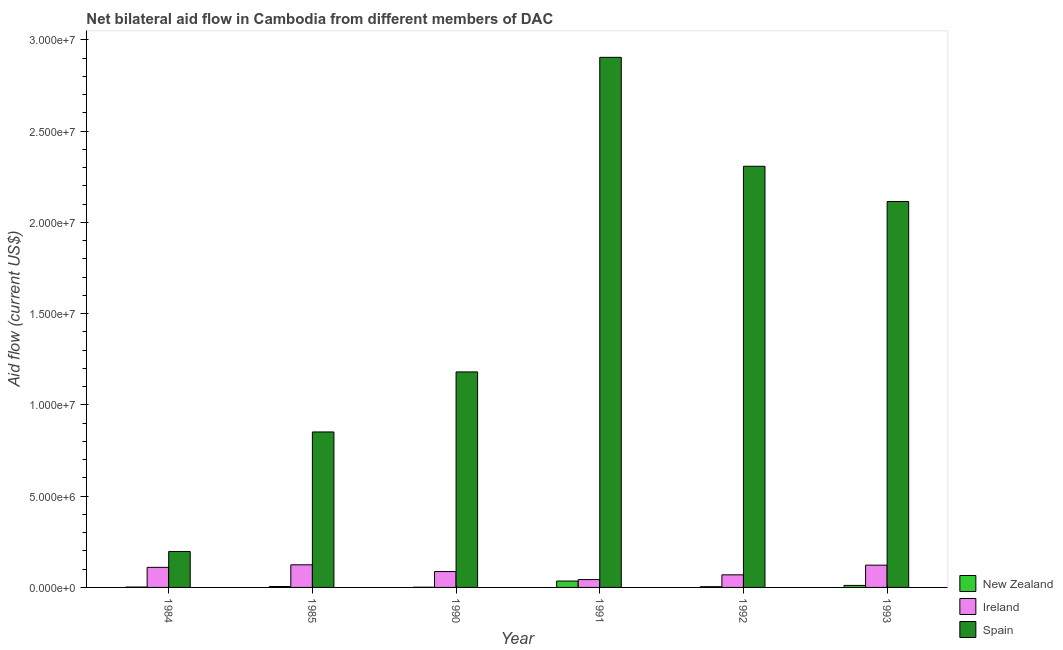Are the number of bars per tick equal to the number of legend labels?
Ensure brevity in your answer.  Yes. How many bars are there on the 4th tick from the left?
Keep it short and to the point. 3. How many bars are there on the 1st tick from the right?
Ensure brevity in your answer.  3. What is the label of the 3rd group of bars from the left?
Offer a terse response. 1990. In how many cases, is the number of bars for a given year not equal to the number of legend labels?
Keep it short and to the point. 0. What is the amount of aid provided by spain in 1993?
Provide a succinct answer. 2.12e+07. Across all years, what is the maximum amount of aid provided by ireland?
Your response must be concise. 1.24e+06. Across all years, what is the minimum amount of aid provided by new zealand?
Provide a succinct answer. 10000. What is the total amount of aid provided by new zealand in the graph?
Provide a succinct answer. 5.80e+05. What is the difference between the amount of aid provided by spain in 1990 and that in 1991?
Your answer should be very brief. -1.72e+07. What is the difference between the amount of aid provided by spain in 1991 and the amount of aid provided by new zealand in 1992?
Give a very brief answer. 5.97e+06. What is the average amount of aid provided by ireland per year?
Your answer should be very brief. 9.25e+05. In the year 1991, what is the difference between the amount of aid provided by spain and amount of aid provided by ireland?
Ensure brevity in your answer.  0. In how many years, is the amount of aid provided by ireland greater than 15000000 US$?
Offer a very short reply. 0. What is the ratio of the amount of aid provided by ireland in 1985 to that in 1991?
Your answer should be compact. 2.88. What is the difference between the highest and the second highest amount of aid provided by spain?
Make the answer very short. 5.97e+06. What is the difference between the highest and the lowest amount of aid provided by new zealand?
Give a very brief answer. 3.40e+05. Is the sum of the amount of aid provided by spain in 1984 and 1993 greater than the maximum amount of aid provided by ireland across all years?
Offer a terse response. No. What does the 2nd bar from the left in 1993 represents?
Your response must be concise. Ireland. What does the 2nd bar from the right in 1985 represents?
Give a very brief answer. Ireland. Is it the case that in every year, the sum of the amount of aid provided by new zealand and amount of aid provided by ireland is greater than the amount of aid provided by spain?
Make the answer very short. No. Are all the bars in the graph horizontal?
Your answer should be very brief. No. What is the difference between two consecutive major ticks on the Y-axis?
Keep it short and to the point. 5.00e+06. Does the graph contain any zero values?
Provide a short and direct response. No. Where does the legend appear in the graph?
Ensure brevity in your answer.  Bottom right. How many legend labels are there?
Provide a short and direct response. 3. How are the legend labels stacked?
Keep it short and to the point. Vertical. What is the title of the graph?
Your response must be concise. Net bilateral aid flow in Cambodia from different members of DAC. What is the label or title of the X-axis?
Provide a short and direct response. Year. What is the label or title of the Y-axis?
Your answer should be very brief. Aid flow (current US$). What is the Aid flow (current US$) in New Zealand in 1984?
Make the answer very short. 2.00e+04. What is the Aid flow (current US$) of Ireland in 1984?
Provide a short and direct response. 1.10e+06. What is the Aid flow (current US$) of Spain in 1984?
Offer a terse response. 1.97e+06. What is the Aid flow (current US$) in New Zealand in 1985?
Your answer should be very brief. 5.00e+04. What is the Aid flow (current US$) of Ireland in 1985?
Provide a short and direct response. 1.24e+06. What is the Aid flow (current US$) of Spain in 1985?
Give a very brief answer. 8.52e+06. What is the Aid flow (current US$) of New Zealand in 1990?
Provide a short and direct response. 10000. What is the Aid flow (current US$) in Ireland in 1990?
Offer a very short reply. 8.70e+05. What is the Aid flow (current US$) of Spain in 1990?
Your response must be concise. 1.18e+07. What is the Aid flow (current US$) of New Zealand in 1991?
Make the answer very short. 3.50e+05. What is the Aid flow (current US$) in Ireland in 1991?
Ensure brevity in your answer.  4.30e+05. What is the Aid flow (current US$) in Spain in 1991?
Make the answer very short. 2.90e+07. What is the Aid flow (current US$) in Ireland in 1992?
Give a very brief answer. 6.90e+05. What is the Aid flow (current US$) of Spain in 1992?
Ensure brevity in your answer.  2.31e+07. What is the Aid flow (current US$) of Ireland in 1993?
Make the answer very short. 1.22e+06. What is the Aid flow (current US$) in Spain in 1993?
Your response must be concise. 2.12e+07. Across all years, what is the maximum Aid flow (current US$) in Ireland?
Your response must be concise. 1.24e+06. Across all years, what is the maximum Aid flow (current US$) of Spain?
Your answer should be compact. 2.90e+07. Across all years, what is the minimum Aid flow (current US$) of New Zealand?
Ensure brevity in your answer.  10000. Across all years, what is the minimum Aid flow (current US$) in Spain?
Offer a terse response. 1.97e+06. What is the total Aid flow (current US$) in New Zealand in the graph?
Your answer should be very brief. 5.80e+05. What is the total Aid flow (current US$) in Ireland in the graph?
Ensure brevity in your answer.  5.55e+06. What is the total Aid flow (current US$) of Spain in the graph?
Ensure brevity in your answer.  9.56e+07. What is the difference between the Aid flow (current US$) of New Zealand in 1984 and that in 1985?
Give a very brief answer. -3.00e+04. What is the difference between the Aid flow (current US$) of Spain in 1984 and that in 1985?
Give a very brief answer. -6.55e+06. What is the difference between the Aid flow (current US$) of New Zealand in 1984 and that in 1990?
Offer a terse response. 10000. What is the difference between the Aid flow (current US$) in Ireland in 1984 and that in 1990?
Offer a terse response. 2.30e+05. What is the difference between the Aid flow (current US$) of Spain in 1984 and that in 1990?
Provide a short and direct response. -9.84e+06. What is the difference between the Aid flow (current US$) of New Zealand in 1984 and that in 1991?
Your answer should be very brief. -3.30e+05. What is the difference between the Aid flow (current US$) in Ireland in 1984 and that in 1991?
Your answer should be very brief. 6.70e+05. What is the difference between the Aid flow (current US$) in Spain in 1984 and that in 1991?
Your response must be concise. -2.71e+07. What is the difference between the Aid flow (current US$) in Spain in 1984 and that in 1992?
Give a very brief answer. -2.11e+07. What is the difference between the Aid flow (current US$) of New Zealand in 1984 and that in 1993?
Ensure brevity in your answer.  -9.00e+04. What is the difference between the Aid flow (current US$) of Spain in 1984 and that in 1993?
Offer a terse response. -1.92e+07. What is the difference between the Aid flow (current US$) of Ireland in 1985 and that in 1990?
Offer a very short reply. 3.70e+05. What is the difference between the Aid flow (current US$) of Spain in 1985 and that in 1990?
Your response must be concise. -3.29e+06. What is the difference between the Aid flow (current US$) of New Zealand in 1985 and that in 1991?
Offer a terse response. -3.00e+05. What is the difference between the Aid flow (current US$) in Ireland in 1985 and that in 1991?
Keep it short and to the point. 8.10e+05. What is the difference between the Aid flow (current US$) of Spain in 1985 and that in 1991?
Provide a short and direct response. -2.05e+07. What is the difference between the Aid flow (current US$) of New Zealand in 1985 and that in 1992?
Your answer should be very brief. 10000. What is the difference between the Aid flow (current US$) in Spain in 1985 and that in 1992?
Provide a succinct answer. -1.46e+07. What is the difference between the Aid flow (current US$) of Ireland in 1985 and that in 1993?
Your response must be concise. 2.00e+04. What is the difference between the Aid flow (current US$) of Spain in 1985 and that in 1993?
Provide a succinct answer. -1.26e+07. What is the difference between the Aid flow (current US$) of New Zealand in 1990 and that in 1991?
Ensure brevity in your answer.  -3.40e+05. What is the difference between the Aid flow (current US$) in Ireland in 1990 and that in 1991?
Keep it short and to the point. 4.40e+05. What is the difference between the Aid flow (current US$) of Spain in 1990 and that in 1991?
Make the answer very short. -1.72e+07. What is the difference between the Aid flow (current US$) of New Zealand in 1990 and that in 1992?
Provide a short and direct response. -3.00e+04. What is the difference between the Aid flow (current US$) in Spain in 1990 and that in 1992?
Offer a very short reply. -1.13e+07. What is the difference between the Aid flow (current US$) in New Zealand in 1990 and that in 1993?
Provide a succinct answer. -1.00e+05. What is the difference between the Aid flow (current US$) in Ireland in 1990 and that in 1993?
Your answer should be compact. -3.50e+05. What is the difference between the Aid flow (current US$) in Spain in 1990 and that in 1993?
Provide a short and direct response. -9.34e+06. What is the difference between the Aid flow (current US$) of Ireland in 1991 and that in 1992?
Offer a very short reply. -2.60e+05. What is the difference between the Aid flow (current US$) of Spain in 1991 and that in 1992?
Your response must be concise. 5.97e+06. What is the difference between the Aid flow (current US$) in Ireland in 1991 and that in 1993?
Your response must be concise. -7.90e+05. What is the difference between the Aid flow (current US$) of Spain in 1991 and that in 1993?
Ensure brevity in your answer.  7.90e+06. What is the difference between the Aid flow (current US$) of New Zealand in 1992 and that in 1993?
Make the answer very short. -7.00e+04. What is the difference between the Aid flow (current US$) of Ireland in 1992 and that in 1993?
Give a very brief answer. -5.30e+05. What is the difference between the Aid flow (current US$) of Spain in 1992 and that in 1993?
Offer a very short reply. 1.93e+06. What is the difference between the Aid flow (current US$) of New Zealand in 1984 and the Aid flow (current US$) of Ireland in 1985?
Keep it short and to the point. -1.22e+06. What is the difference between the Aid flow (current US$) in New Zealand in 1984 and the Aid flow (current US$) in Spain in 1985?
Offer a very short reply. -8.50e+06. What is the difference between the Aid flow (current US$) in Ireland in 1984 and the Aid flow (current US$) in Spain in 1985?
Your answer should be compact. -7.42e+06. What is the difference between the Aid flow (current US$) of New Zealand in 1984 and the Aid flow (current US$) of Ireland in 1990?
Ensure brevity in your answer.  -8.50e+05. What is the difference between the Aid flow (current US$) in New Zealand in 1984 and the Aid flow (current US$) in Spain in 1990?
Your answer should be very brief. -1.18e+07. What is the difference between the Aid flow (current US$) in Ireland in 1984 and the Aid flow (current US$) in Spain in 1990?
Give a very brief answer. -1.07e+07. What is the difference between the Aid flow (current US$) of New Zealand in 1984 and the Aid flow (current US$) of Ireland in 1991?
Your response must be concise. -4.10e+05. What is the difference between the Aid flow (current US$) in New Zealand in 1984 and the Aid flow (current US$) in Spain in 1991?
Keep it short and to the point. -2.90e+07. What is the difference between the Aid flow (current US$) in Ireland in 1984 and the Aid flow (current US$) in Spain in 1991?
Keep it short and to the point. -2.80e+07. What is the difference between the Aid flow (current US$) in New Zealand in 1984 and the Aid flow (current US$) in Ireland in 1992?
Give a very brief answer. -6.70e+05. What is the difference between the Aid flow (current US$) in New Zealand in 1984 and the Aid flow (current US$) in Spain in 1992?
Ensure brevity in your answer.  -2.31e+07. What is the difference between the Aid flow (current US$) of Ireland in 1984 and the Aid flow (current US$) of Spain in 1992?
Give a very brief answer. -2.20e+07. What is the difference between the Aid flow (current US$) in New Zealand in 1984 and the Aid flow (current US$) in Ireland in 1993?
Offer a very short reply. -1.20e+06. What is the difference between the Aid flow (current US$) in New Zealand in 1984 and the Aid flow (current US$) in Spain in 1993?
Ensure brevity in your answer.  -2.11e+07. What is the difference between the Aid flow (current US$) of Ireland in 1984 and the Aid flow (current US$) of Spain in 1993?
Make the answer very short. -2.00e+07. What is the difference between the Aid flow (current US$) in New Zealand in 1985 and the Aid flow (current US$) in Ireland in 1990?
Your response must be concise. -8.20e+05. What is the difference between the Aid flow (current US$) of New Zealand in 1985 and the Aid flow (current US$) of Spain in 1990?
Give a very brief answer. -1.18e+07. What is the difference between the Aid flow (current US$) in Ireland in 1985 and the Aid flow (current US$) in Spain in 1990?
Make the answer very short. -1.06e+07. What is the difference between the Aid flow (current US$) of New Zealand in 1985 and the Aid flow (current US$) of Ireland in 1991?
Provide a succinct answer. -3.80e+05. What is the difference between the Aid flow (current US$) of New Zealand in 1985 and the Aid flow (current US$) of Spain in 1991?
Provide a short and direct response. -2.90e+07. What is the difference between the Aid flow (current US$) in Ireland in 1985 and the Aid flow (current US$) in Spain in 1991?
Your response must be concise. -2.78e+07. What is the difference between the Aid flow (current US$) in New Zealand in 1985 and the Aid flow (current US$) in Ireland in 1992?
Offer a very short reply. -6.40e+05. What is the difference between the Aid flow (current US$) of New Zealand in 1985 and the Aid flow (current US$) of Spain in 1992?
Ensure brevity in your answer.  -2.30e+07. What is the difference between the Aid flow (current US$) of Ireland in 1985 and the Aid flow (current US$) of Spain in 1992?
Your answer should be compact. -2.18e+07. What is the difference between the Aid flow (current US$) of New Zealand in 1985 and the Aid flow (current US$) of Ireland in 1993?
Provide a short and direct response. -1.17e+06. What is the difference between the Aid flow (current US$) of New Zealand in 1985 and the Aid flow (current US$) of Spain in 1993?
Keep it short and to the point. -2.11e+07. What is the difference between the Aid flow (current US$) in Ireland in 1985 and the Aid flow (current US$) in Spain in 1993?
Offer a very short reply. -1.99e+07. What is the difference between the Aid flow (current US$) of New Zealand in 1990 and the Aid flow (current US$) of Ireland in 1991?
Your answer should be very brief. -4.20e+05. What is the difference between the Aid flow (current US$) in New Zealand in 1990 and the Aid flow (current US$) in Spain in 1991?
Make the answer very short. -2.90e+07. What is the difference between the Aid flow (current US$) in Ireland in 1990 and the Aid flow (current US$) in Spain in 1991?
Make the answer very short. -2.82e+07. What is the difference between the Aid flow (current US$) of New Zealand in 1990 and the Aid flow (current US$) of Ireland in 1992?
Ensure brevity in your answer.  -6.80e+05. What is the difference between the Aid flow (current US$) of New Zealand in 1990 and the Aid flow (current US$) of Spain in 1992?
Offer a terse response. -2.31e+07. What is the difference between the Aid flow (current US$) of Ireland in 1990 and the Aid flow (current US$) of Spain in 1992?
Your response must be concise. -2.22e+07. What is the difference between the Aid flow (current US$) of New Zealand in 1990 and the Aid flow (current US$) of Ireland in 1993?
Your response must be concise. -1.21e+06. What is the difference between the Aid flow (current US$) in New Zealand in 1990 and the Aid flow (current US$) in Spain in 1993?
Ensure brevity in your answer.  -2.11e+07. What is the difference between the Aid flow (current US$) of Ireland in 1990 and the Aid flow (current US$) of Spain in 1993?
Offer a terse response. -2.03e+07. What is the difference between the Aid flow (current US$) of New Zealand in 1991 and the Aid flow (current US$) of Spain in 1992?
Your answer should be very brief. -2.27e+07. What is the difference between the Aid flow (current US$) of Ireland in 1991 and the Aid flow (current US$) of Spain in 1992?
Keep it short and to the point. -2.26e+07. What is the difference between the Aid flow (current US$) in New Zealand in 1991 and the Aid flow (current US$) in Ireland in 1993?
Offer a very short reply. -8.70e+05. What is the difference between the Aid flow (current US$) of New Zealand in 1991 and the Aid flow (current US$) of Spain in 1993?
Offer a terse response. -2.08e+07. What is the difference between the Aid flow (current US$) of Ireland in 1991 and the Aid flow (current US$) of Spain in 1993?
Make the answer very short. -2.07e+07. What is the difference between the Aid flow (current US$) in New Zealand in 1992 and the Aid flow (current US$) in Ireland in 1993?
Provide a succinct answer. -1.18e+06. What is the difference between the Aid flow (current US$) of New Zealand in 1992 and the Aid flow (current US$) of Spain in 1993?
Give a very brief answer. -2.11e+07. What is the difference between the Aid flow (current US$) in Ireland in 1992 and the Aid flow (current US$) in Spain in 1993?
Offer a terse response. -2.05e+07. What is the average Aid flow (current US$) in New Zealand per year?
Your response must be concise. 9.67e+04. What is the average Aid flow (current US$) of Ireland per year?
Your response must be concise. 9.25e+05. What is the average Aid flow (current US$) in Spain per year?
Give a very brief answer. 1.59e+07. In the year 1984, what is the difference between the Aid flow (current US$) of New Zealand and Aid flow (current US$) of Ireland?
Your response must be concise. -1.08e+06. In the year 1984, what is the difference between the Aid flow (current US$) in New Zealand and Aid flow (current US$) in Spain?
Offer a terse response. -1.95e+06. In the year 1984, what is the difference between the Aid flow (current US$) in Ireland and Aid flow (current US$) in Spain?
Make the answer very short. -8.70e+05. In the year 1985, what is the difference between the Aid flow (current US$) of New Zealand and Aid flow (current US$) of Ireland?
Offer a terse response. -1.19e+06. In the year 1985, what is the difference between the Aid flow (current US$) of New Zealand and Aid flow (current US$) of Spain?
Provide a short and direct response. -8.47e+06. In the year 1985, what is the difference between the Aid flow (current US$) in Ireland and Aid flow (current US$) in Spain?
Ensure brevity in your answer.  -7.28e+06. In the year 1990, what is the difference between the Aid flow (current US$) in New Zealand and Aid flow (current US$) in Ireland?
Provide a short and direct response. -8.60e+05. In the year 1990, what is the difference between the Aid flow (current US$) in New Zealand and Aid flow (current US$) in Spain?
Provide a short and direct response. -1.18e+07. In the year 1990, what is the difference between the Aid flow (current US$) of Ireland and Aid flow (current US$) of Spain?
Your answer should be very brief. -1.09e+07. In the year 1991, what is the difference between the Aid flow (current US$) in New Zealand and Aid flow (current US$) in Ireland?
Your answer should be very brief. -8.00e+04. In the year 1991, what is the difference between the Aid flow (current US$) in New Zealand and Aid flow (current US$) in Spain?
Give a very brief answer. -2.87e+07. In the year 1991, what is the difference between the Aid flow (current US$) of Ireland and Aid flow (current US$) of Spain?
Offer a very short reply. -2.86e+07. In the year 1992, what is the difference between the Aid flow (current US$) of New Zealand and Aid flow (current US$) of Ireland?
Provide a succinct answer. -6.50e+05. In the year 1992, what is the difference between the Aid flow (current US$) of New Zealand and Aid flow (current US$) of Spain?
Give a very brief answer. -2.30e+07. In the year 1992, what is the difference between the Aid flow (current US$) of Ireland and Aid flow (current US$) of Spain?
Make the answer very short. -2.24e+07. In the year 1993, what is the difference between the Aid flow (current US$) of New Zealand and Aid flow (current US$) of Ireland?
Your answer should be compact. -1.11e+06. In the year 1993, what is the difference between the Aid flow (current US$) of New Zealand and Aid flow (current US$) of Spain?
Offer a terse response. -2.10e+07. In the year 1993, what is the difference between the Aid flow (current US$) of Ireland and Aid flow (current US$) of Spain?
Your answer should be very brief. -1.99e+07. What is the ratio of the Aid flow (current US$) of New Zealand in 1984 to that in 1985?
Offer a very short reply. 0.4. What is the ratio of the Aid flow (current US$) in Ireland in 1984 to that in 1985?
Offer a very short reply. 0.89. What is the ratio of the Aid flow (current US$) of Spain in 1984 to that in 1985?
Provide a succinct answer. 0.23. What is the ratio of the Aid flow (current US$) in New Zealand in 1984 to that in 1990?
Your answer should be compact. 2. What is the ratio of the Aid flow (current US$) in Ireland in 1984 to that in 1990?
Offer a very short reply. 1.26. What is the ratio of the Aid flow (current US$) of Spain in 1984 to that in 1990?
Ensure brevity in your answer.  0.17. What is the ratio of the Aid flow (current US$) in New Zealand in 1984 to that in 1991?
Keep it short and to the point. 0.06. What is the ratio of the Aid flow (current US$) in Ireland in 1984 to that in 1991?
Give a very brief answer. 2.56. What is the ratio of the Aid flow (current US$) in Spain in 1984 to that in 1991?
Your answer should be very brief. 0.07. What is the ratio of the Aid flow (current US$) of Ireland in 1984 to that in 1992?
Keep it short and to the point. 1.59. What is the ratio of the Aid flow (current US$) in Spain in 1984 to that in 1992?
Provide a short and direct response. 0.09. What is the ratio of the Aid flow (current US$) in New Zealand in 1984 to that in 1993?
Provide a succinct answer. 0.18. What is the ratio of the Aid flow (current US$) of Ireland in 1984 to that in 1993?
Provide a short and direct response. 0.9. What is the ratio of the Aid flow (current US$) of Spain in 1984 to that in 1993?
Ensure brevity in your answer.  0.09. What is the ratio of the Aid flow (current US$) in New Zealand in 1985 to that in 1990?
Your answer should be very brief. 5. What is the ratio of the Aid flow (current US$) of Ireland in 1985 to that in 1990?
Your answer should be very brief. 1.43. What is the ratio of the Aid flow (current US$) in Spain in 1985 to that in 1990?
Your answer should be compact. 0.72. What is the ratio of the Aid flow (current US$) in New Zealand in 1985 to that in 1991?
Offer a terse response. 0.14. What is the ratio of the Aid flow (current US$) of Ireland in 1985 to that in 1991?
Offer a terse response. 2.88. What is the ratio of the Aid flow (current US$) in Spain in 1985 to that in 1991?
Provide a short and direct response. 0.29. What is the ratio of the Aid flow (current US$) of New Zealand in 1985 to that in 1992?
Offer a very short reply. 1.25. What is the ratio of the Aid flow (current US$) in Ireland in 1985 to that in 1992?
Offer a terse response. 1.8. What is the ratio of the Aid flow (current US$) in Spain in 1985 to that in 1992?
Ensure brevity in your answer.  0.37. What is the ratio of the Aid flow (current US$) in New Zealand in 1985 to that in 1993?
Offer a very short reply. 0.45. What is the ratio of the Aid flow (current US$) of Ireland in 1985 to that in 1993?
Your answer should be very brief. 1.02. What is the ratio of the Aid flow (current US$) in Spain in 1985 to that in 1993?
Provide a short and direct response. 0.4. What is the ratio of the Aid flow (current US$) of New Zealand in 1990 to that in 1991?
Your answer should be compact. 0.03. What is the ratio of the Aid flow (current US$) in Ireland in 1990 to that in 1991?
Provide a succinct answer. 2.02. What is the ratio of the Aid flow (current US$) of Spain in 1990 to that in 1991?
Offer a terse response. 0.41. What is the ratio of the Aid flow (current US$) in Ireland in 1990 to that in 1992?
Your answer should be very brief. 1.26. What is the ratio of the Aid flow (current US$) in Spain in 1990 to that in 1992?
Give a very brief answer. 0.51. What is the ratio of the Aid flow (current US$) of New Zealand in 1990 to that in 1993?
Make the answer very short. 0.09. What is the ratio of the Aid flow (current US$) of Ireland in 1990 to that in 1993?
Keep it short and to the point. 0.71. What is the ratio of the Aid flow (current US$) of Spain in 1990 to that in 1993?
Your response must be concise. 0.56. What is the ratio of the Aid flow (current US$) of New Zealand in 1991 to that in 1992?
Provide a short and direct response. 8.75. What is the ratio of the Aid flow (current US$) of Ireland in 1991 to that in 1992?
Your answer should be very brief. 0.62. What is the ratio of the Aid flow (current US$) in Spain in 1991 to that in 1992?
Your response must be concise. 1.26. What is the ratio of the Aid flow (current US$) of New Zealand in 1991 to that in 1993?
Your answer should be compact. 3.18. What is the ratio of the Aid flow (current US$) in Ireland in 1991 to that in 1993?
Offer a terse response. 0.35. What is the ratio of the Aid flow (current US$) in Spain in 1991 to that in 1993?
Ensure brevity in your answer.  1.37. What is the ratio of the Aid flow (current US$) of New Zealand in 1992 to that in 1993?
Your answer should be compact. 0.36. What is the ratio of the Aid flow (current US$) of Ireland in 1992 to that in 1993?
Give a very brief answer. 0.57. What is the ratio of the Aid flow (current US$) of Spain in 1992 to that in 1993?
Your response must be concise. 1.09. What is the difference between the highest and the second highest Aid flow (current US$) of Spain?
Keep it short and to the point. 5.97e+06. What is the difference between the highest and the lowest Aid flow (current US$) in New Zealand?
Give a very brief answer. 3.40e+05. What is the difference between the highest and the lowest Aid flow (current US$) of Ireland?
Your answer should be very brief. 8.10e+05. What is the difference between the highest and the lowest Aid flow (current US$) in Spain?
Make the answer very short. 2.71e+07. 